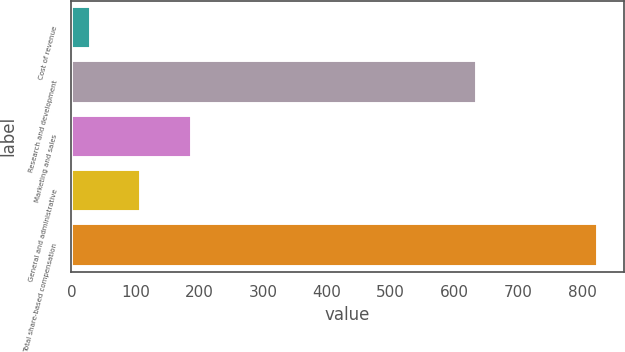Convert chart to OTSL. <chart><loc_0><loc_0><loc_500><loc_500><bar_chart><fcel>Cost of revenue<fcel>Research and development<fcel>Marketing and sales<fcel>General and administrative<fcel>Total share-based compensation<nl><fcel>30<fcel>636<fcel>188.8<fcel>109.4<fcel>824<nl></chart> 